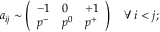<formula> <loc_0><loc_0><loc_500><loc_500>a _ { i j } \sim \left ( \begin{array} { l l l } { - 1 } & { 0 } & { + 1 } \\ { p ^ { - } } & { p ^ { 0 } } & { p ^ { + } } \end{array} \right ) \quad \forall \, i < j ;</formula> 